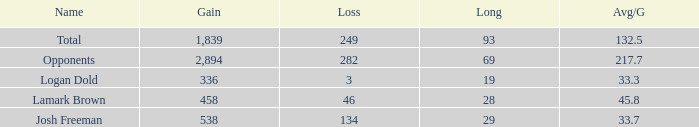Which Long is the highest one that has a Loss larger than 3, and a Gain larger than 2,894? None. 